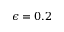<formula> <loc_0><loc_0><loc_500><loc_500>\epsilon = 0 . 2</formula> 